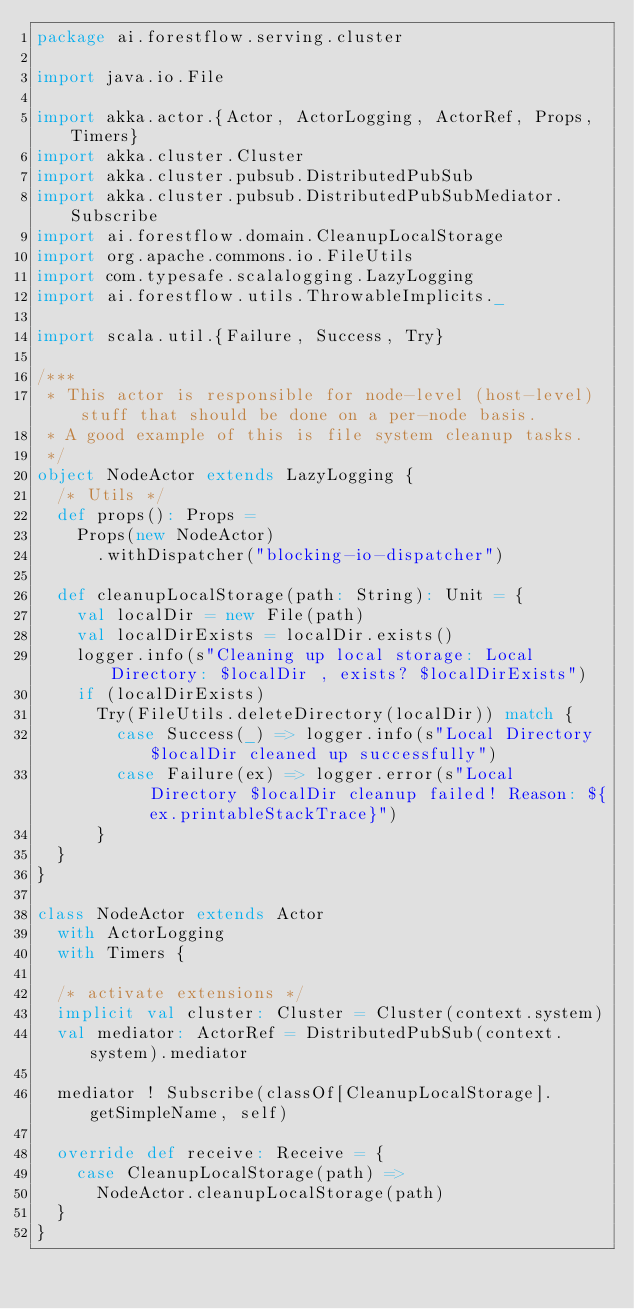Convert code to text. <code><loc_0><loc_0><loc_500><loc_500><_Scala_>package ai.forestflow.serving.cluster

import java.io.File

import akka.actor.{Actor, ActorLogging, ActorRef, Props, Timers}
import akka.cluster.Cluster
import akka.cluster.pubsub.DistributedPubSub
import akka.cluster.pubsub.DistributedPubSubMediator.Subscribe
import ai.forestflow.domain.CleanupLocalStorage
import org.apache.commons.io.FileUtils
import com.typesafe.scalalogging.LazyLogging
import ai.forestflow.utils.ThrowableImplicits._

import scala.util.{Failure, Success, Try}

/***
 * This actor is responsible for node-level (host-level) stuff that should be done on a per-node basis.
 * A good example of this is file system cleanup tasks.
 */
object NodeActor extends LazyLogging {
  /* Utils */
  def props(): Props =
    Props(new NodeActor)
      .withDispatcher("blocking-io-dispatcher")

  def cleanupLocalStorage(path: String): Unit = {
    val localDir = new File(path)
    val localDirExists = localDir.exists()
    logger.info(s"Cleaning up local storage: Local Directory: $localDir , exists? $localDirExists")
    if (localDirExists)
      Try(FileUtils.deleteDirectory(localDir)) match {
        case Success(_) => logger.info(s"Local Directory $localDir cleaned up successfully")
        case Failure(ex) => logger.error(s"Local Directory $localDir cleanup failed! Reason: ${ex.printableStackTrace}")
      }
  }
}

class NodeActor extends Actor
  with ActorLogging
  with Timers {

  /* activate extensions */
  implicit val cluster: Cluster = Cluster(context.system)
  val mediator: ActorRef = DistributedPubSub(context.system).mediator

  mediator ! Subscribe(classOf[CleanupLocalStorage].getSimpleName, self)

  override def receive: Receive = {
    case CleanupLocalStorage(path) =>
      NodeActor.cleanupLocalStorage(path)
  }
}
</code> 